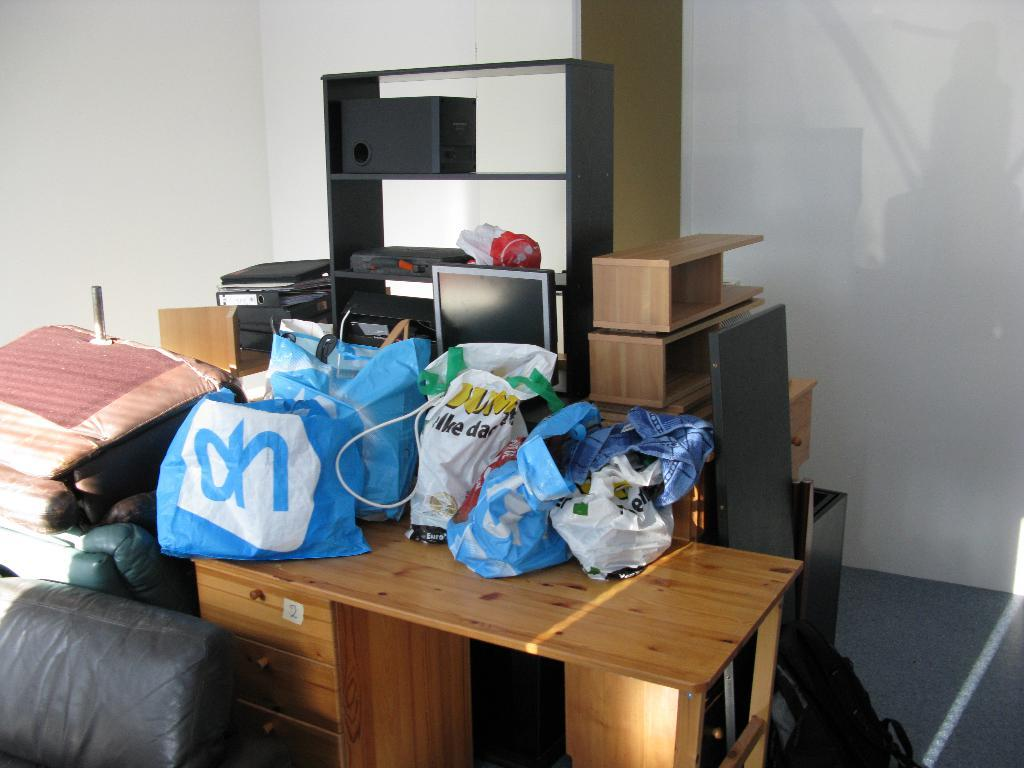<image>
Describe the image concisely. The desk under a pile of shopping bags is labeled with the number 2. 